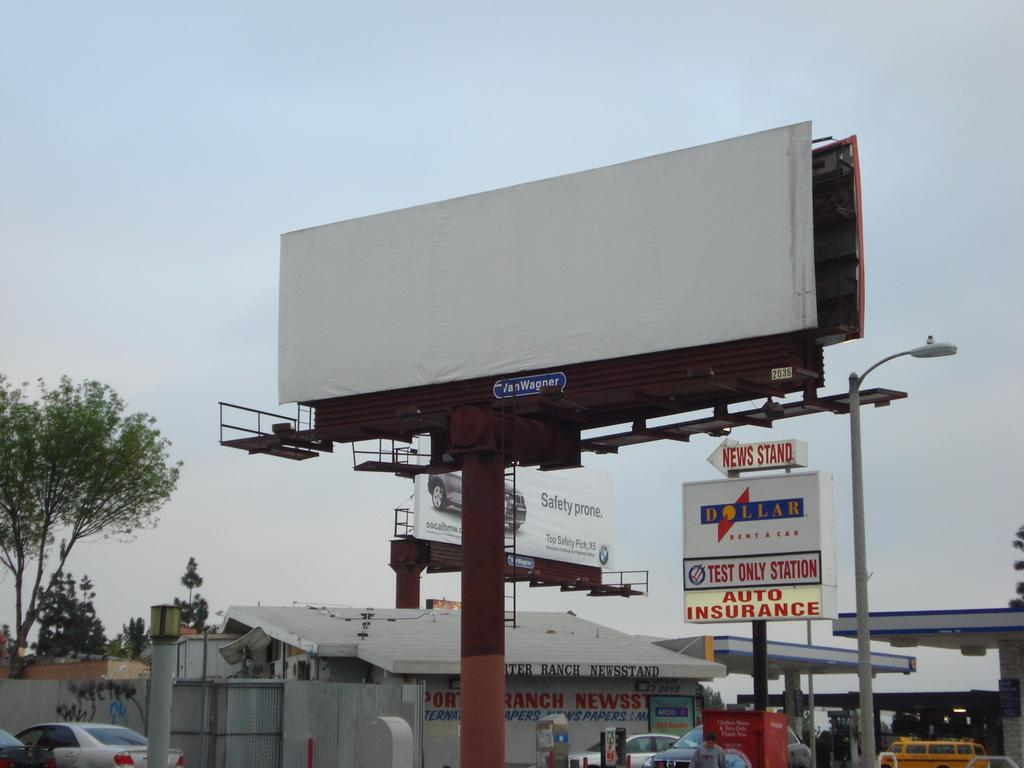<image>
Give a short and clear explanation of the subsequent image. The sign shows there is a news stand to the left of the billboard. 